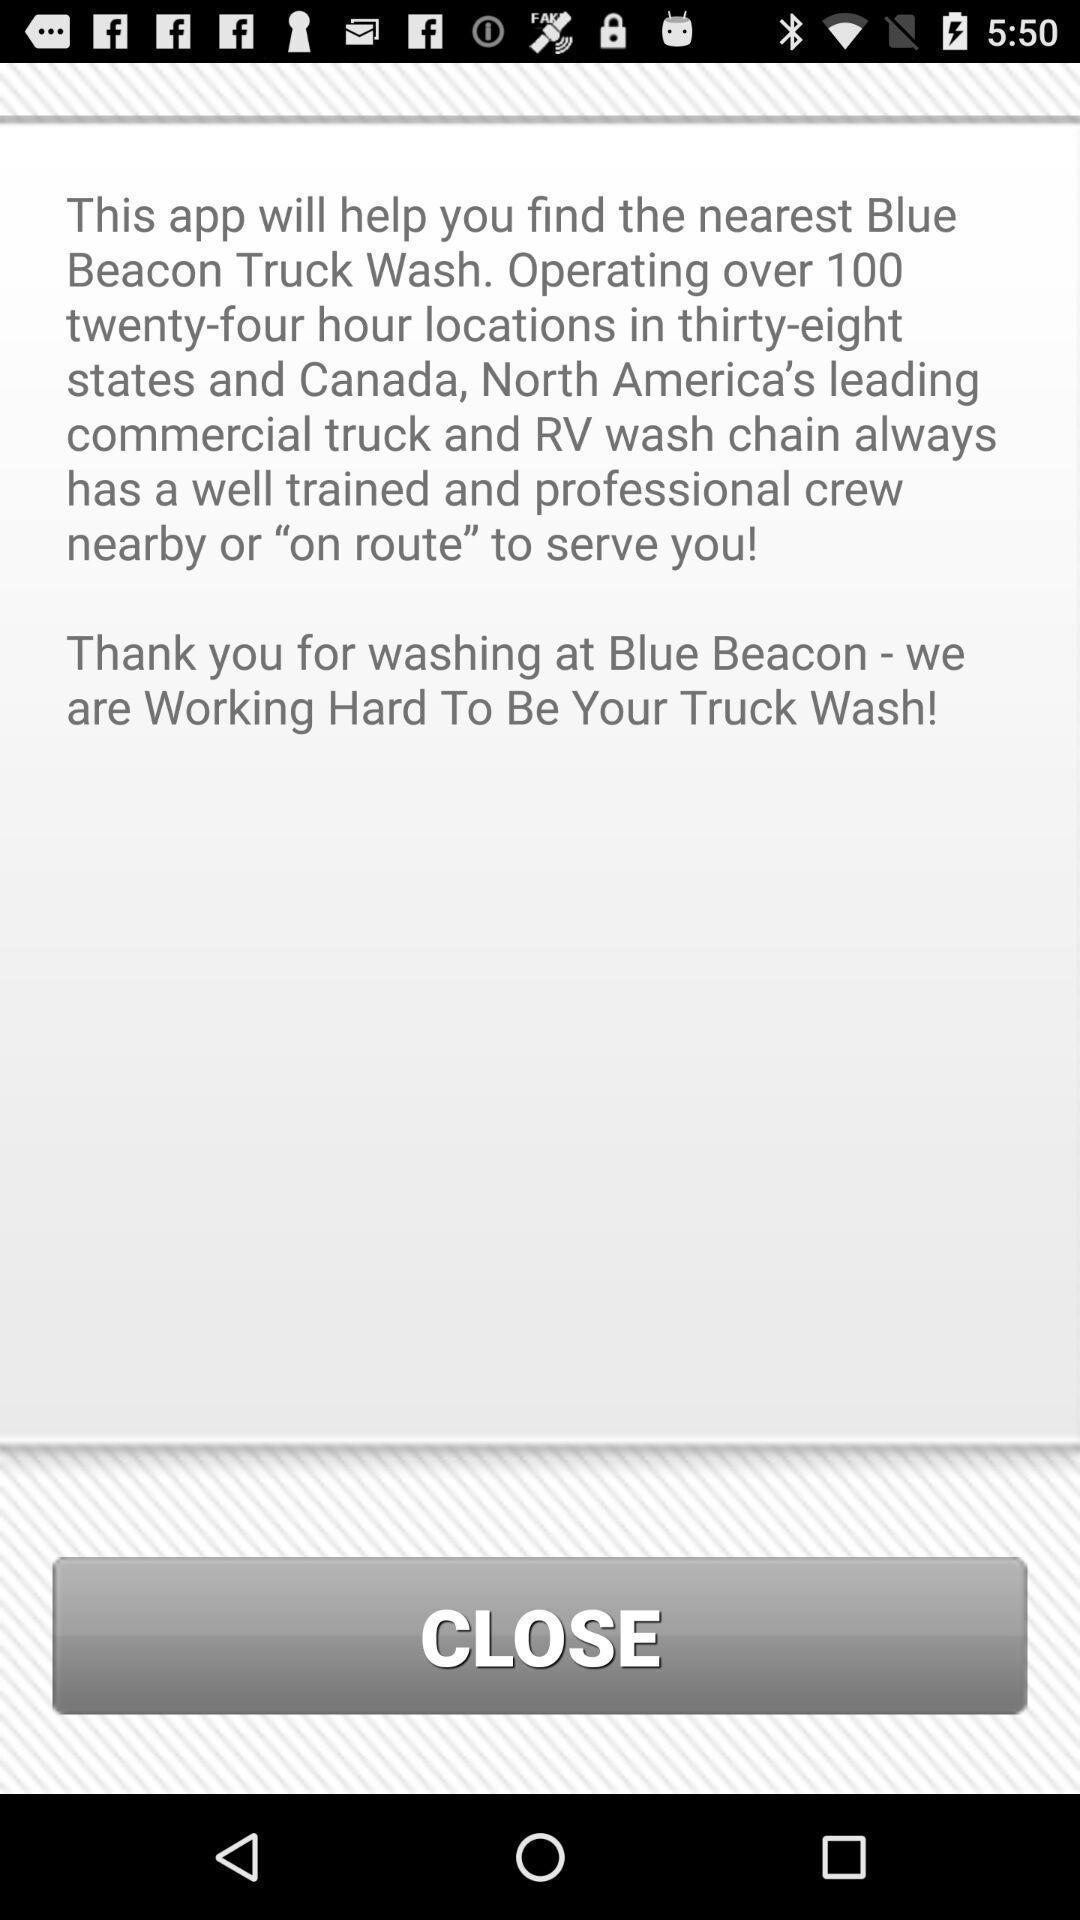Tell me what you see in this picture. Screen showing about the application. 